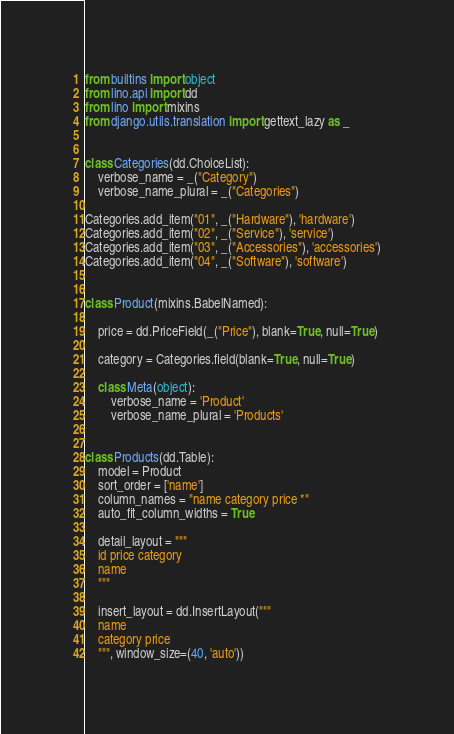<code> <loc_0><loc_0><loc_500><loc_500><_Python_>from builtins import object
from lino.api import dd
from lino import mixins
from django.utils.translation import gettext_lazy as _


class Categories(dd.ChoiceList):
    verbose_name = _("Category")
    verbose_name_plural = _("Categories")

Categories.add_item("01", _("Hardware"), 'hardware')
Categories.add_item("02", _("Service"), 'service')
Categories.add_item("03", _("Accessories"), 'accessories')
Categories.add_item("04", _("Software"), 'software')


class Product(mixins.BabelNamed):

    price = dd.PriceField(_("Price"), blank=True, null=True)

    category = Categories.field(blank=True, null=True)

    class Meta(object):
        verbose_name = 'Product'
        verbose_name_plural = 'Products'


class Products(dd.Table):
    model = Product
    sort_order = ['name']
    column_names = "name category price *"
    auto_fit_column_widths = True

    detail_layout = """
    id price category
    name
    """

    insert_layout = dd.InsertLayout("""
    name
    category price
    """, window_size=(40, 'auto'))


</code> 